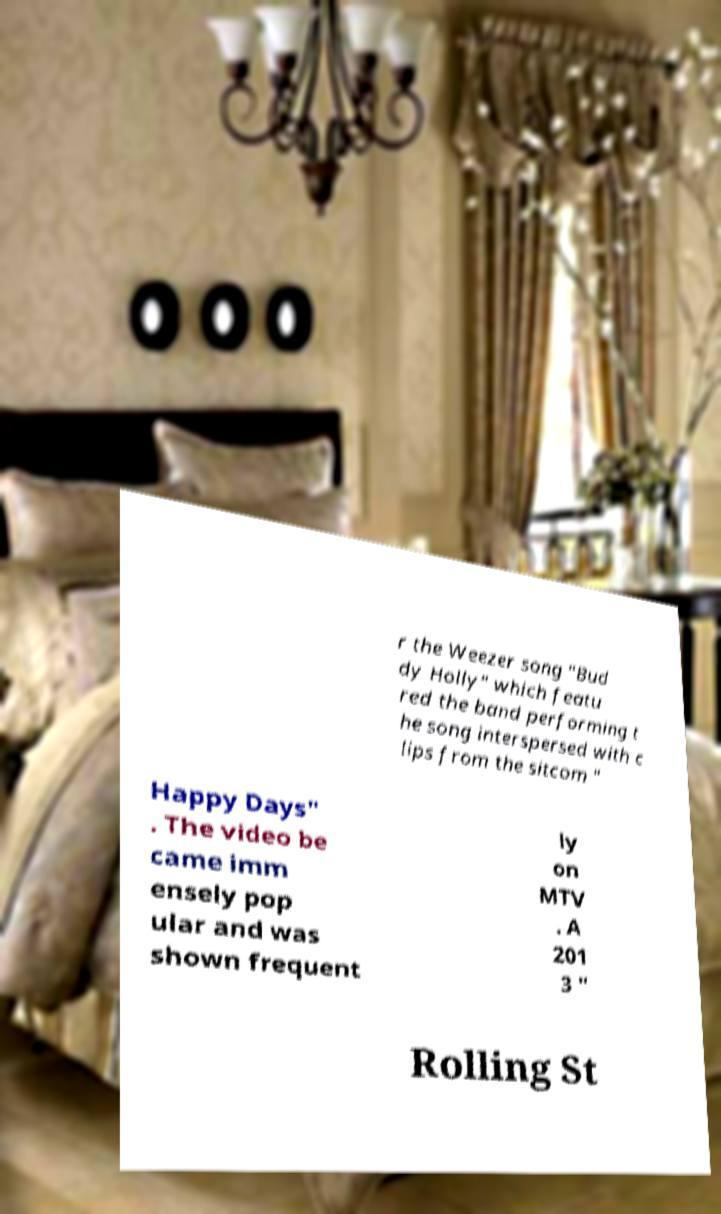Can you accurately transcribe the text from the provided image for me? r the Weezer song "Bud dy Holly" which featu red the band performing t he song interspersed with c lips from the sitcom " Happy Days" . The video be came imm ensely pop ular and was shown frequent ly on MTV . A 201 3 " Rolling St 